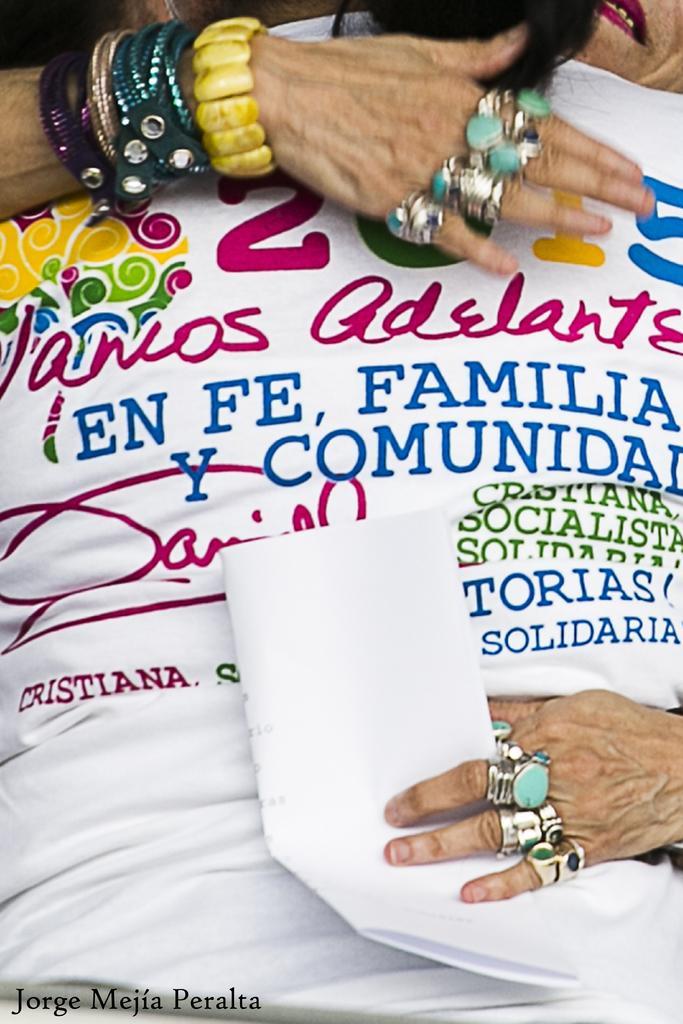Could you give a brief overview of what you see in this image? Here we can see a person is hugging another person and there are texts written on the t-shirt and there are bands and rings to the hands and fingers and at the bottom there is a paper in a person hand. 